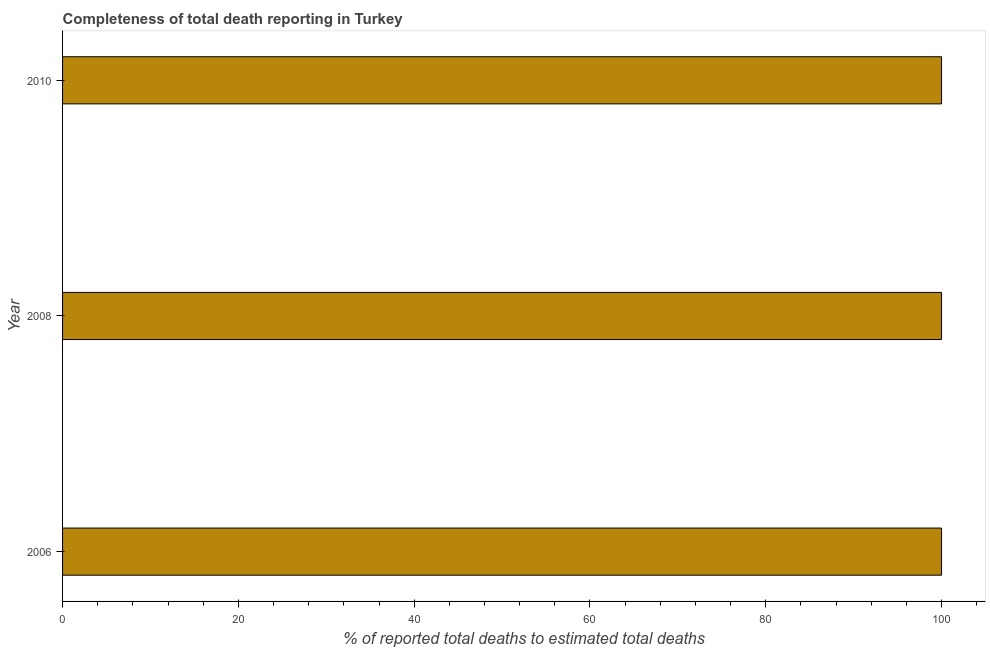What is the title of the graph?
Offer a terse response. Completeness of total death reporting in Turkey. What is the label or title of the X-axis?
Offer a terse response. % of reported total deaths to estimated total deaths. What is the label or title of the Y-axis?
Make the answer very short. Year. Across all years, what is the maximum completeness of total death reports?
Provide a succinct answer. 100. Across all years, what is the minimum completeness of total death reports?
Provide a short and direct response. 100. What is the sum of the completeness of total death reports?
Offer a very short reply. 300. What is the average completeness of total death reports per year?
Ensure brevity in your answer.  100. What is the median completeness of total death reports?
Offer a very short reply. 100. What is the ratio of the completeness of total death reports in 2006 to that in 2008?
Offer a terse response. 1. Is the completeness of total death reports in 2008 less than that in 2010?
Make the answer very short. No. Is the difference between the completeness of total death reports in 2006 and 2010 greater than the difference between any two years?
Your answer should be compact. Yes. What is the difference between the highest and the second highest completeness of total death reports?
Offer a terse response. 0. What is the difference between the highest and the lowest completeness of total death reports?
Keep it short and to the point. 0. In how many years, is the completeness of total death reports greater than the average completeness of total death reports taken over all years?
Make the answer very short. 0. How many bars are there?
Give a very brief answer. 3. How many years are there in the graph?
Keep it short and to the point. 3. What is the difference between two consecutive major ticks on the X-axis?
Your answer should be very brief. 20. Are the values on the major ticks of X-axis written in scientific E-notation?
Give a very brief answer. No. What is the % of reported total deaths to estimated total deaths in 2006?
Ensure brevity in your answer.  100. What is the % of reported total deaths to estimated total deaths of 2010?
Keep it short and to the point. 100. What is the difference between the % of reported total deaths to estimated total deaths in 2006 and 2008?
Your response must be concise. 0. What is the difference between the % of reported total deaths to estimated total deaths in 2006 and 2010?
Provide a short and direct response. 0. What is the difference between the % of reported total deaths to estimated total deaths in 2008 and 2010?
Keep it short and to the point. 0. What is the ratio of the % of reported total deaths to estimated total deaths in 2006 to that in 2008?
Offer a very short reply. 1. What is the ratio of the % of reported total deaths to estimated total deaths in 2008 to that in 2010?
Provide a short and direct response. 1. 